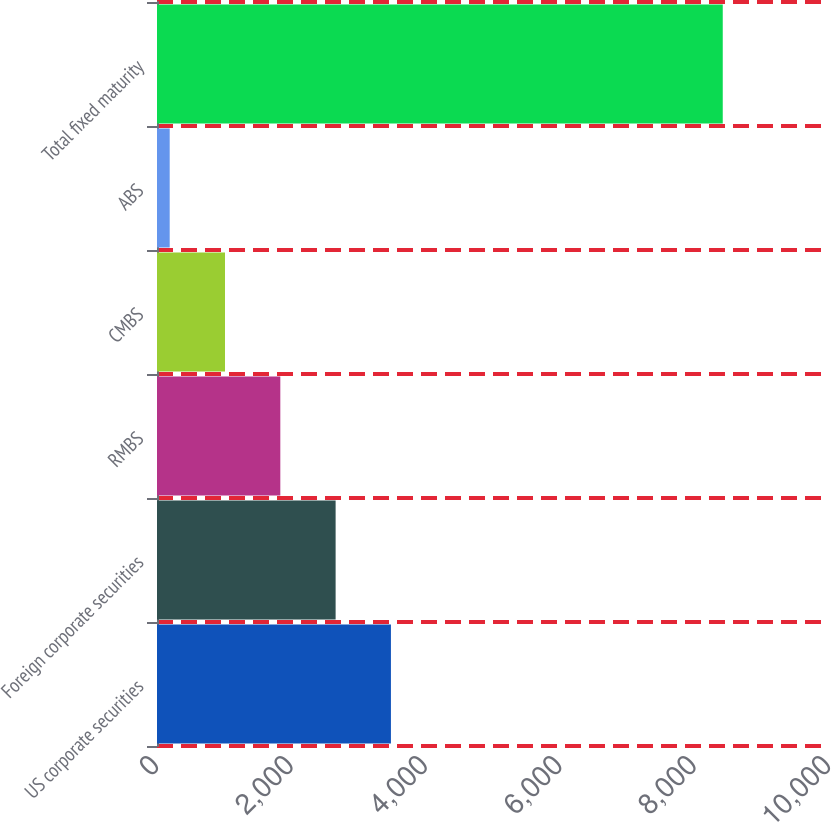<chart> <loc_0><loc_0><loc_500><loc_500><bar_chart><fcel>US corporate securities<fcel>Foreign corporate securities<fcel>RMBS<fcel>CMBS<fcel>ABS<fcel>Total fixed maturity<nl><fcel>3481<fcel>2658<fcel>1835<fcel>1012<fcel>189<fcel>8419<nl></chart> 